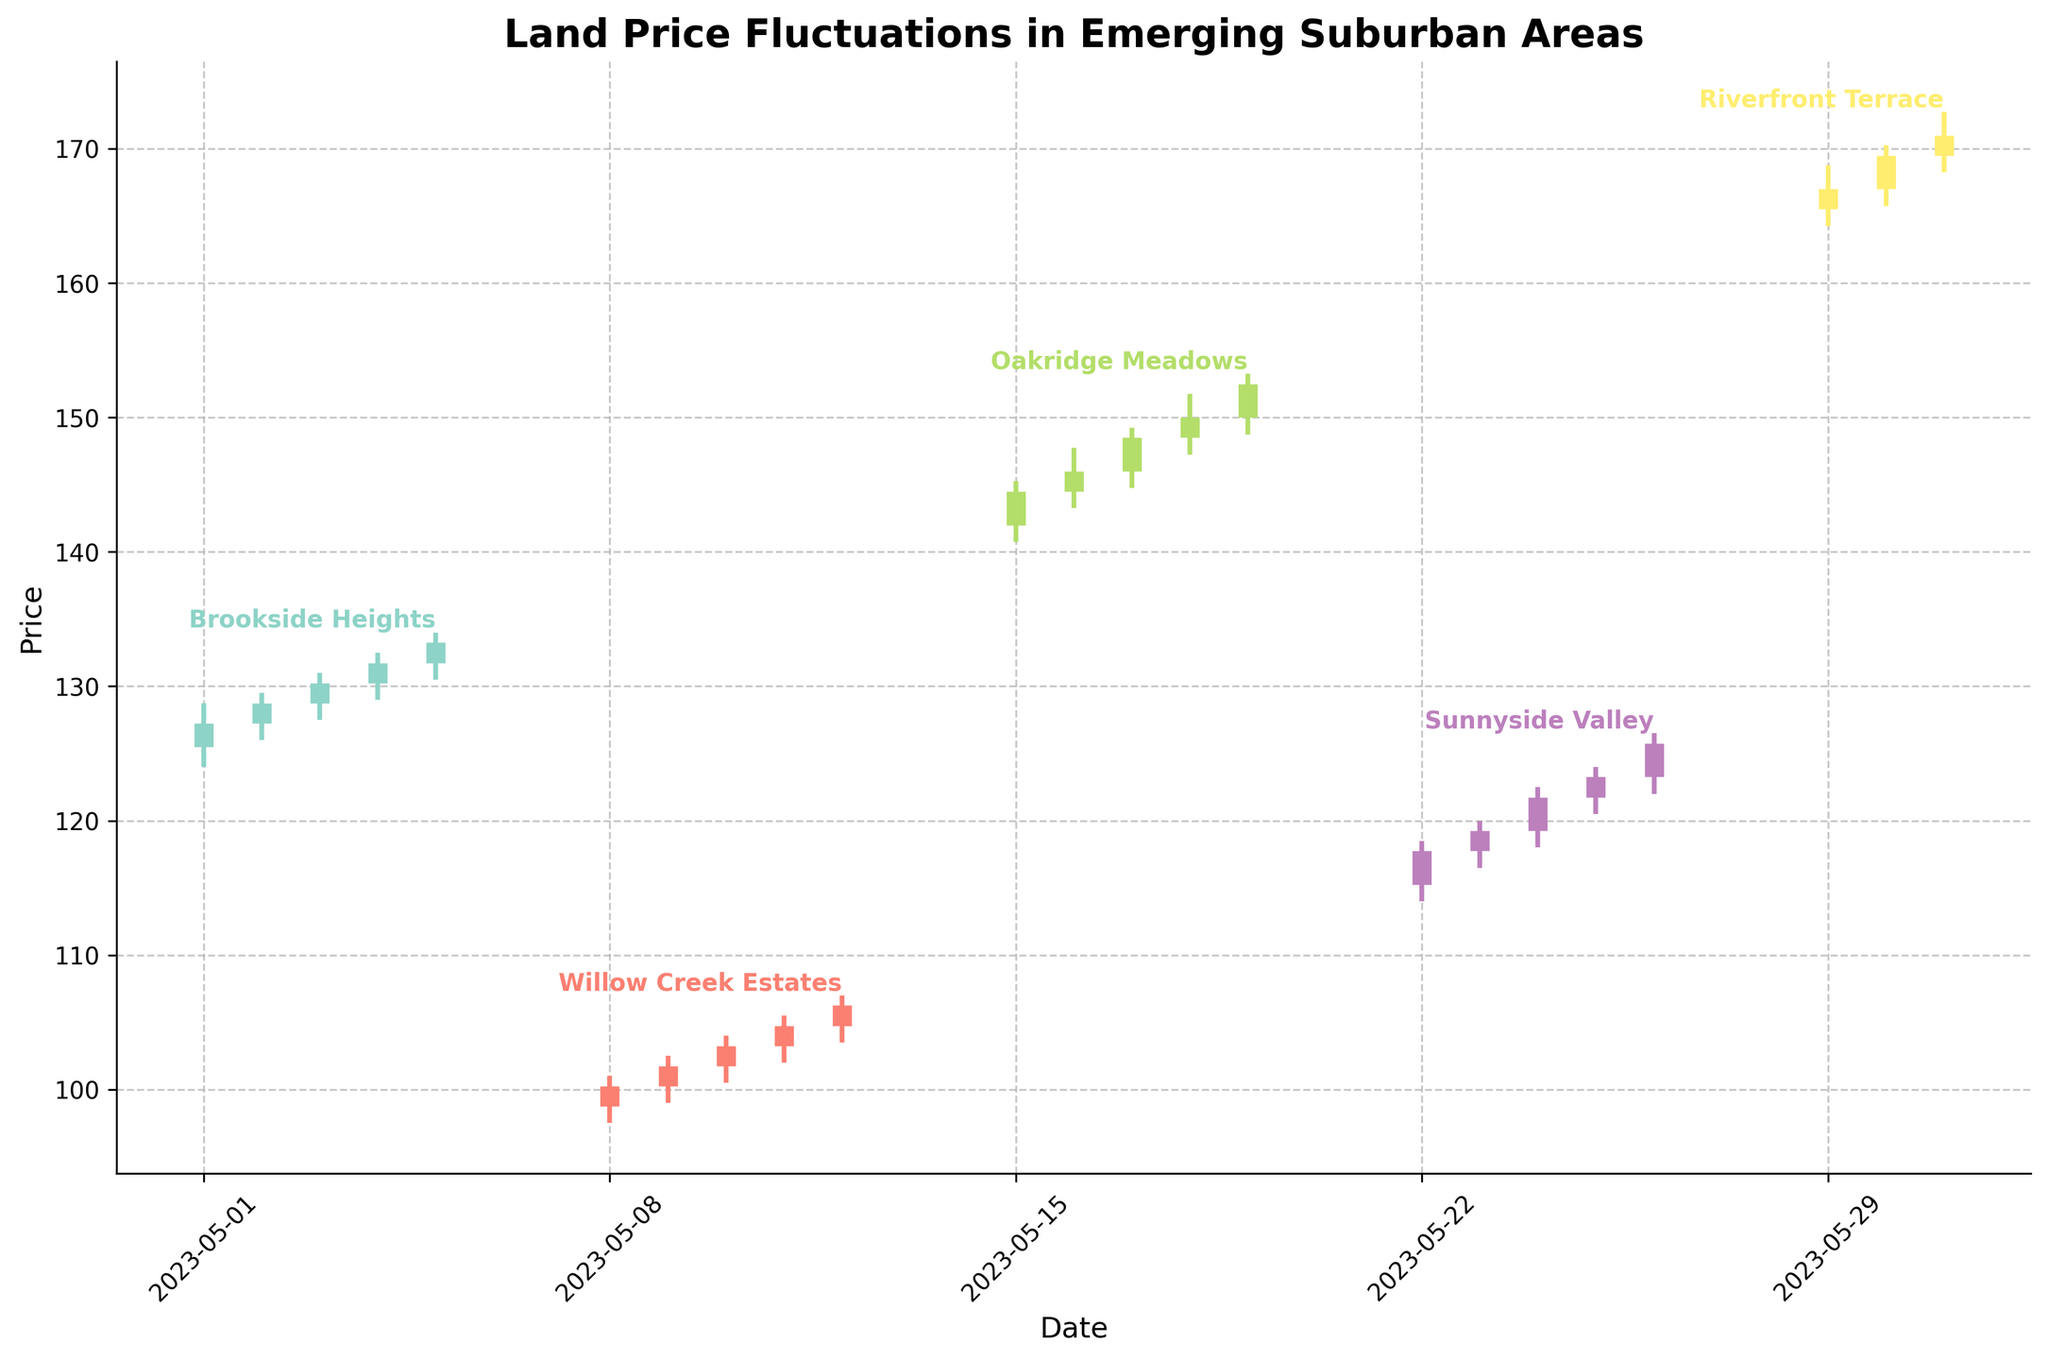what is the title of the chart? The title of the chart is located at the top of the figure. It is meant to summarize the main subject of the plotted data. In this case, the title describes what the chart is representing, which is the fluctuation of land prices in different emerging suburban areas.
Answer: Land Price Fluctuations in Emerging Suburban Areas which area has the lowest price on its first day of data? To determine the area with the lowest price on its first day of data, we'll check the lowest opening price among the different areas. The first day for each area can be identified by looking at the start of their respective lines.
Answer: Willow Creek Estates which area experienced the largest price increase in a single day? To find the area with the largest price increase in a single day, we need to look at the daily differences between "Open" and "Close" prices for all areas. Subtract the "Open" from "Close" for each day and identify the maximum difference.
Answer: Riverfront Terrace compare the price trends between Brookside Heights and Sunnyside Valley. Which area had a more consistent upward trend? To compare the price trends between Brookside Heights and Sunnyside Valley, we check whether both areas have a consistent 'Open' and 'Close' trend over their respective date ranges. A consistent upward trend means "Close" prices are consistently higher than "Open" prices. Brookside Heights shows a steady increase in "Close" prices over days.
Answer: Brookside Heights what are the highest and lowest prices for Riverfront Terrace during May? To find the highest and lowest prices for Riverfront Terrace during May, we look at the "High" and "Low" values within the date range associated with the area. Identify the maximum "High" and the minimum "Low" values among those listed for Riverfront Terrace.
Answer: Highest: 172.75, Lowest: 164.25 How does the closing price of Oakridge Meadows change over the dates plotted? To assess the change in closing price of Oakridge Meadows over the given dates, we look at the "Close" values for the days relevant to Oakridge Meadows. Note these from the provided data and compare the sequence to understand the trend.
Answer: The closing prices of Oakridge Meadows show an upward trend from 144.50 to 152.50 which day had the highest difference between the high and low prices in Brookside Heights, and what is the amount? To find the day with the highest difference between high and low prices in Brookside Heights, calculate the difference (High - Low) for each day. Identify the maximum difference and the corresponding date.
Answer: 2023-05-01, 4.75 compare the closing prices on May 5 for Brookside Heights and May 12 for Willow Creek Estates. Which one is higher? To compare these closing prices, check the "Close" value on May 5 for Brookside Heights and on May 12 for Willow Creek Estates. The one with the higher value indicates the higher closing price.
Answer: Brookside Heights, 133.25 